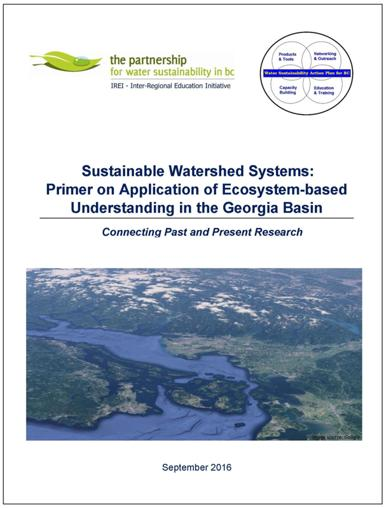Can you tell me more about the Georgia Basin and why it is significant for watershed studies? The Georgia Basin is a critical ecological region located in British Columbia, Canada, known for its rich biodiversity and the presence of significant watersheds that are vital for the surrounding communities and natural habitats. It's an important study area for watershed management because it faces challenges like urbanization and climate change, which demand innovative and sustainable approaches to ensure long-term ecological health and water quality. 